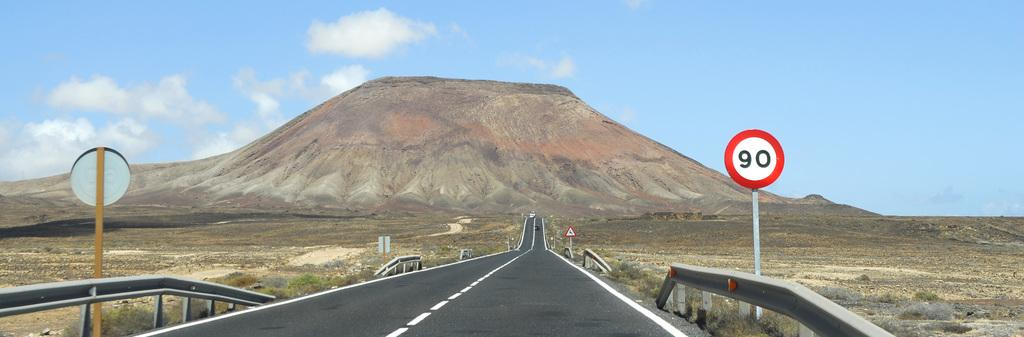<image>
Create a compact narrative representing the image presented. empty road with no cars insight and a street sign 90 